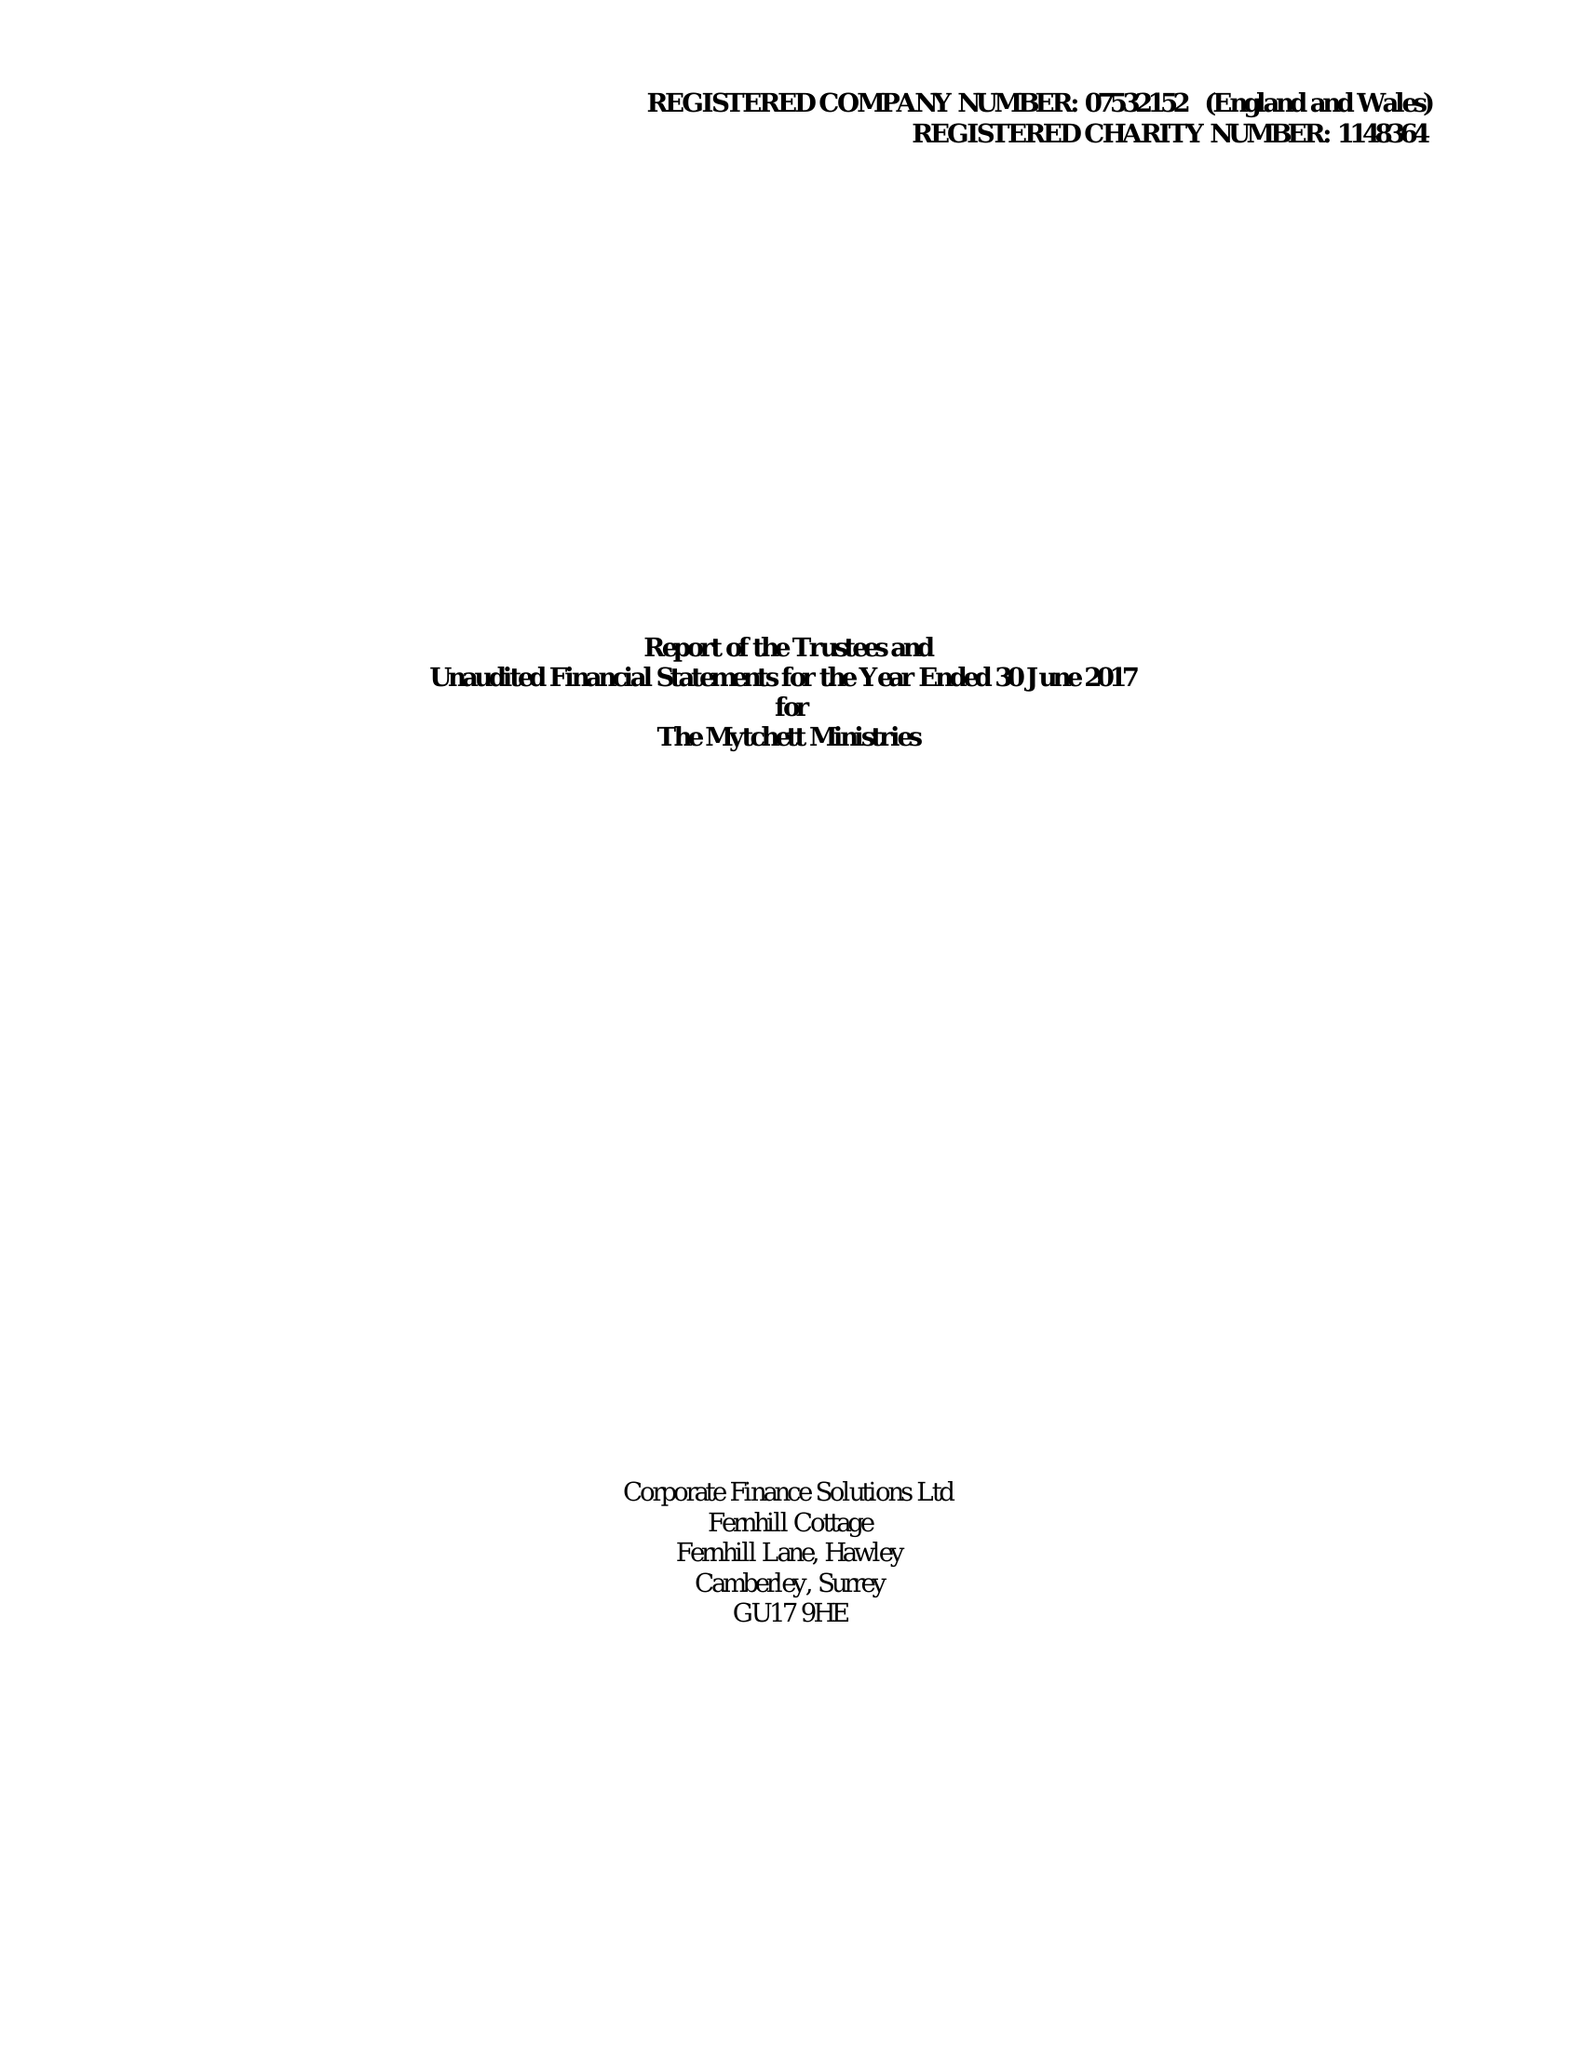What is the value for the spending_annually_in_british_pounds?
Answer the question using a single word or phrase. 88207.00 